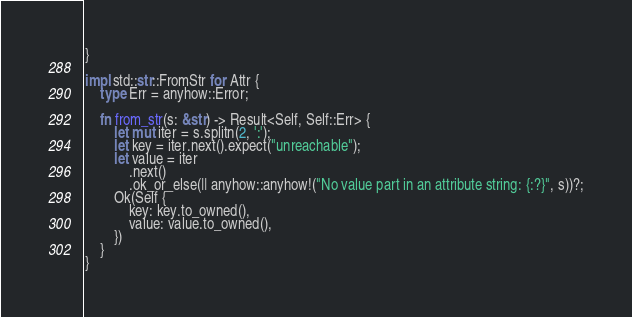Convert code to text. <code><loc_0><loc_0><loc_500><loc_500><_Rust_>}

impl std::str::FromStr for Attr {
    type Err = anyhow::Error;

    fn from_str(s: &str) -> Result<Self, Self::Err> {
        let mut iter = s.splitn(2, ':');
        let key = iter.next().expect("unreachable");
        let value = iter
            .next()
            .ok_or_else(|| anyhow::anyhow!("No value part in an attribute string: {:?}", s))?;
        Ok(Self {
            key: key.to_owned(),
            value: value.to_owned(),
        })
    }
}
</code> 